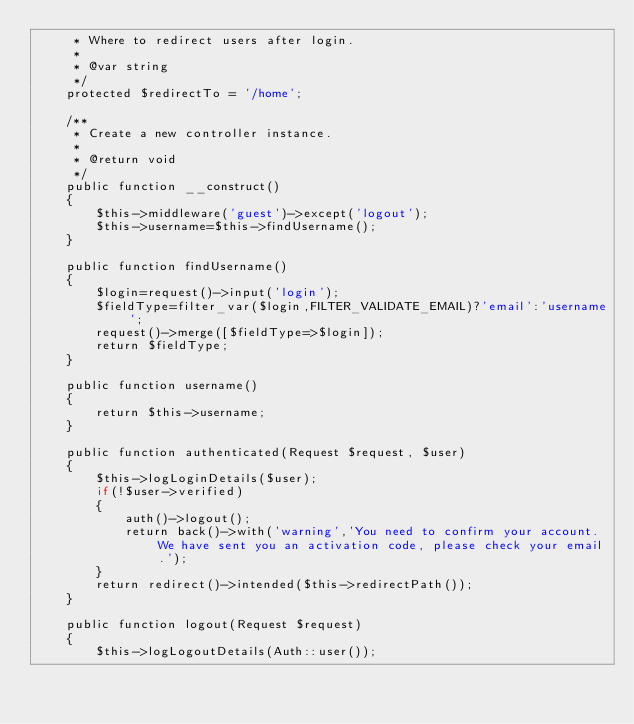<code> <loc_0><loc_0><loc_500><loc_500><_PHP_>     * Where to redirect users after login.
     *
     * @var string
     */
    protected $redirectTo = '/home';

    /**
     * Create a new controller instance.
     *
     * @return void
     */
    public function __construct()
    {
        $this->middleware('guest')->except('logout');
        $this->username=$this->findUsername();
    }

    public function findUsername()
    {
        $login=request()->input('login');
        $fieldType=filter_var($login,FILTER_VALIDATE_EMAIL)?'email':'username';
        request()->merge([$fieldType=>$login]);
        return $fieldType;
    }

    public function username()
    {
        return $this->username;
    }

    public function authenticated(Request $request, $user)
    {
        $this->logLoginDetails($user);
        if(!$user->verified)
        {
            auth()->logout();
            return back()->with('warning','You need to confirm your account. We have sent you an activation code, please check your email.');
        }
        return redirect()->intended($this->redirectPath());
    }

    public function logout(Request $request)
    {
        $this->logLogoutDetails(Auth::user());</code> 